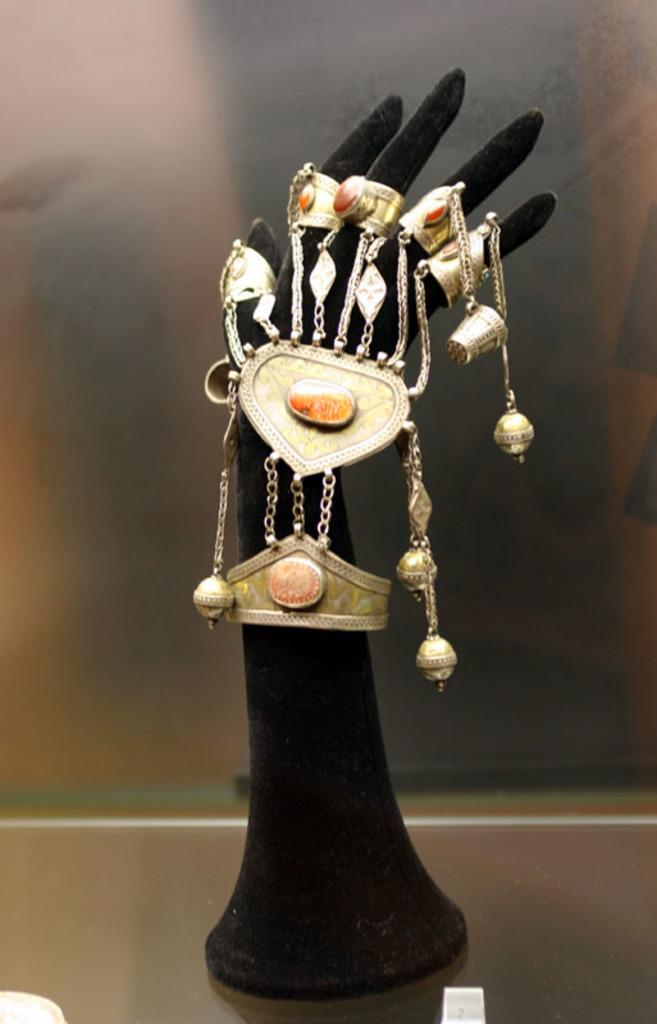What can be seen in the image? There are objects in the image. What colors are the objects? The objects are black and golden in color. Where are the objects located in the image? The objects are located in the center of the image. How does the pain affect the prose in the image? There is no pain or prose present in the image; it only features objects that are black and golden in color and located in the center. 